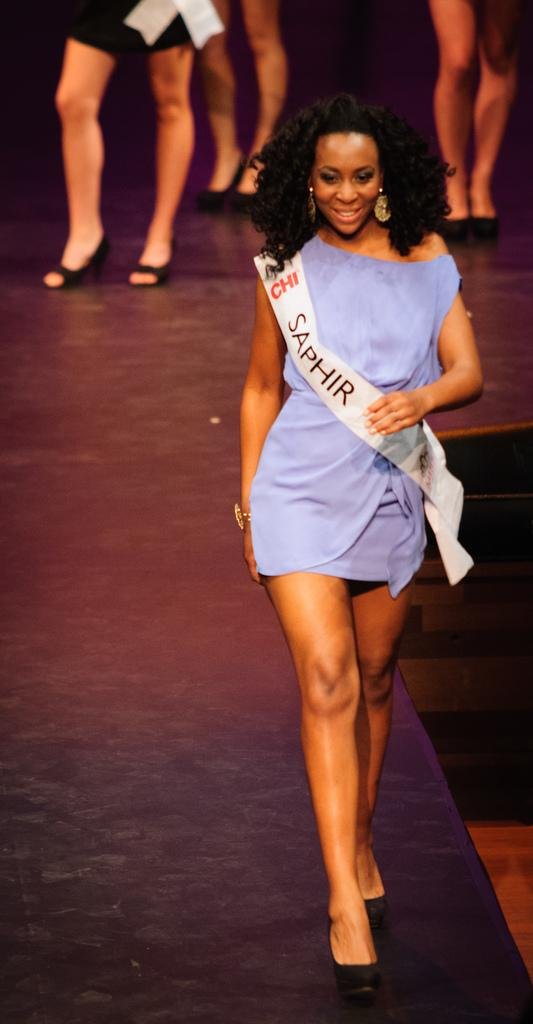Who is the main subject in the image? There is a woman in the image. What is the woman wearing? The woman is wearing a violet color dress and a sash. What is the woman doing in the image? The woman is walking on a ramp. Can you describe the background of the image? The background of the image shows the legs of other women, suggesting that they are also walking on the ramp. What type of fork can be seen in the woman's hand in the image? There is no fork present in the image; the woman is not holding any utensils. 